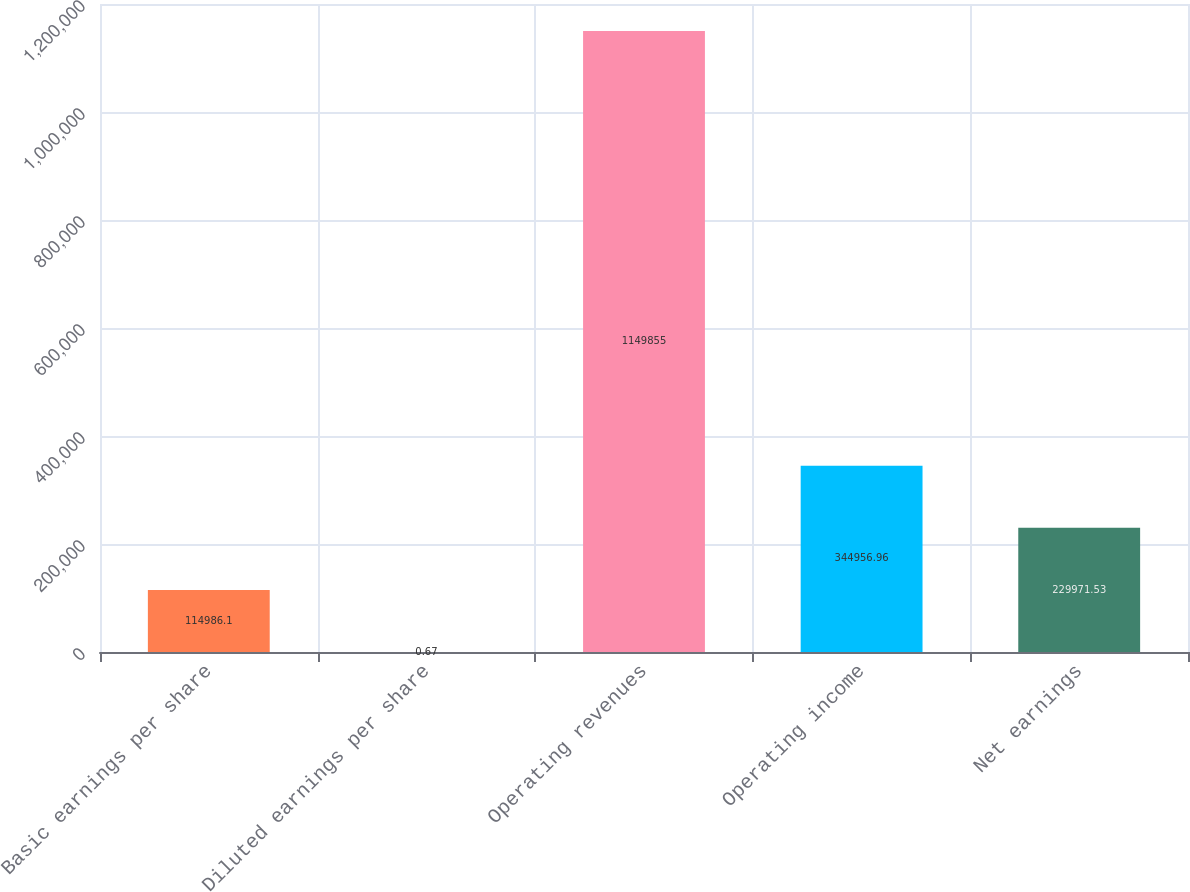<chart> <loc_0><loc_0><loc_500><loc_500><bar_chart><fcel>Basic earnings per share<fcel>Diluted earnings per share<fcel>Operating revenues<fcel>Operating income<fcel>Net earnings<nl><fcel>114986<fcel>0.67<fcel>1.14986e+06<fcel>344957<fcel>229972<nl></chart> 